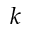Convert formula to latex. <formula><loc_0><loc_0><loc_500><loc_500>k</formula> 